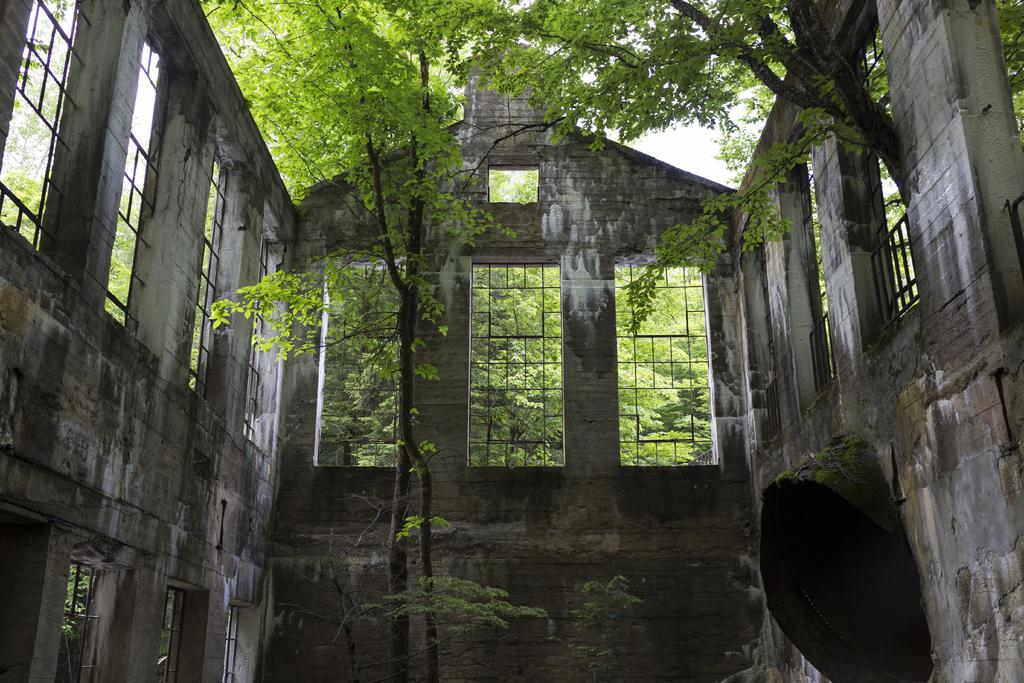What is the main object in the foreground of the image? There is a tree in the image. What is the tree surrounded by? The tree is surrounded by a wall. What feature can be seen on the wall? The wall has windows. What can be seen in the background of the image? There are trees and the sky visible in the background of the image. What type of reaction does the son have when he sees the market in the image? There is no market or son present in the image, so it is not possible to answer that question. 